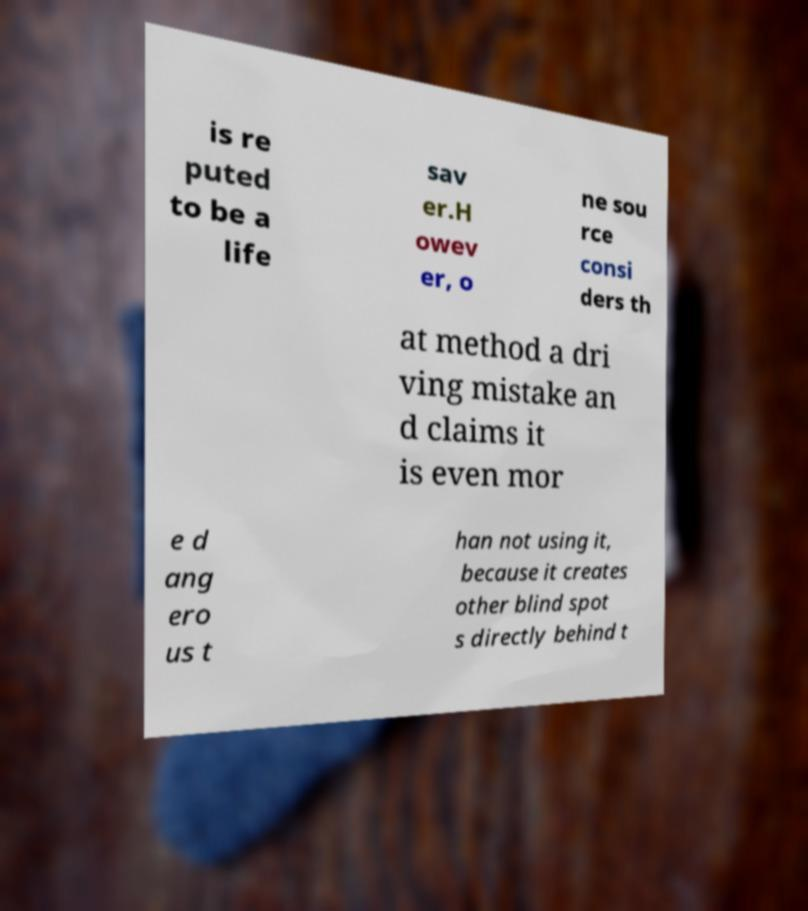Could you extract and type out the text from this image? is re puted to be a life sav er.H owev er, o ne sou rce consi ders th at method a dri ving mistake an d claims it is even mor e d ang ero us t han not using it, because it creates other blind spot s directly behind t 